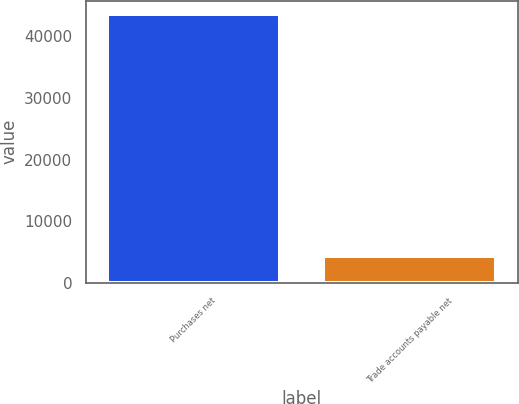<chart> <loc_0><loc_0><loc_500><loc_500><bar_chart><fcel>Purchases net<fcel>Trade accounts payable net<nl><fcel>43571<fcel>4384<nl></chart> 